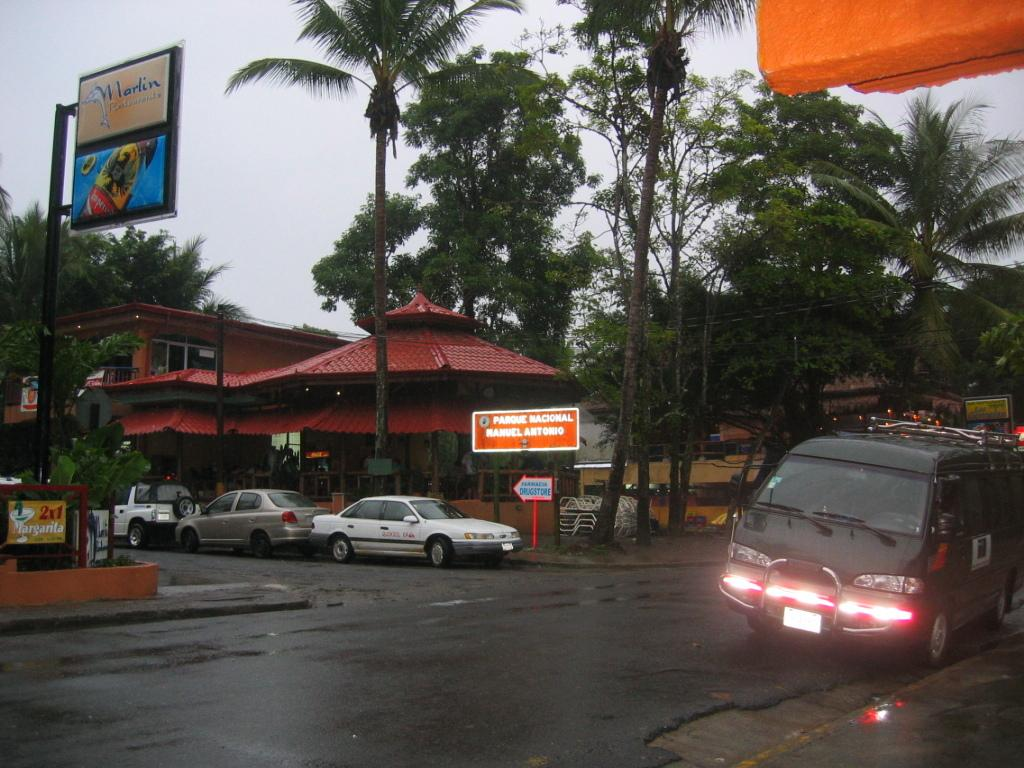What can be seen in the foreground of the image? There are vehicles on the road in the foreground of the image. What type of objects are visible in the image besides vehicles? Boards, trees, cables, poles, buildings, and the sky are visible in the image. What might be used for supporting or transmitting something in the image? Cables and poles are present in the image for supporting or transmitting something. How many types of structures can be seen in the image? There are at least two types of structures visible in the image: buildings and poles. Where is the box located in the image? There is no box present in the image. What type of game can be seen being played in the image? There is no game or play activity depicted in the image. 